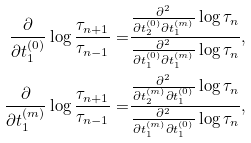<formula> <loc_0><loc_0><loc_500><loc_500>\frac { \partial } { \partial t ^ { ( 0 ) } _ { 1 } } \log \frac { \tau _ { n + 1 } } { \tau _ { n - 1 } } = & \frac { \frac { \partial ^ { 2 } } { \partial t ^ { ( 0 ) } _ { 2 } \partial t ^ { ( m ) } _ { 1 } } \log \tau _ { n } } { \frac { \partial ^ { 2 } } { \partial t ^ { ( 0 ) } _ { 1 } \partial t ^ { ( m ) } _ { 1 } } \log \tau _ { n } } , \\ \frac { \partial } { \partial t ^ { ( m ) } _ { 1 } } \log \frac { \tau _ { n + 1 } } { \tau _ { n - 1 } } = & \frac { \frac { \partial ^ { 2 } } { \partial t ^ { ( m ) } _ { 2 } \partial t ^ { ( 0 ) } _ { 1 } } \log \tau _ { n } } { \frac { \partial ^ { 2 } } { \partial t ^ { ( m ) } _ { 1 } \partial t ^ { ( 0 ) } _ { 1 } } \log \tau _ { n } } ,</formula> 